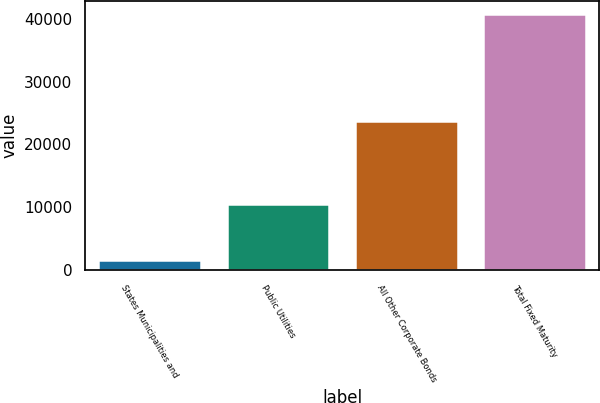Convert chart. <chart><loc_0><loc_0><loc_500><loc_500><bar_chart><fcel>States Municipalities and<fcel>Public Utilities<fcel>All Other Corporate Bonds<fcel>Total Fixed Maturity<nl><fcel>1625.1<fcel>10485.6<fcel>23755.5<fcel>40766.3<nl></chart> 